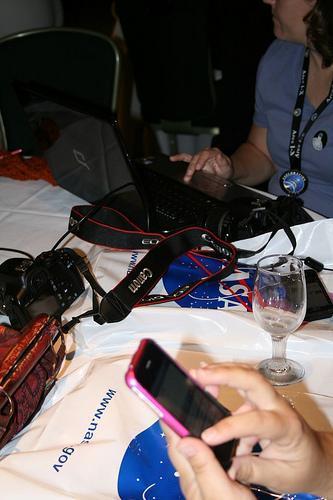How many people are there?
Give a very brief answer. 2. How many white surfboards are there?
Give a very brief answer. 0. 